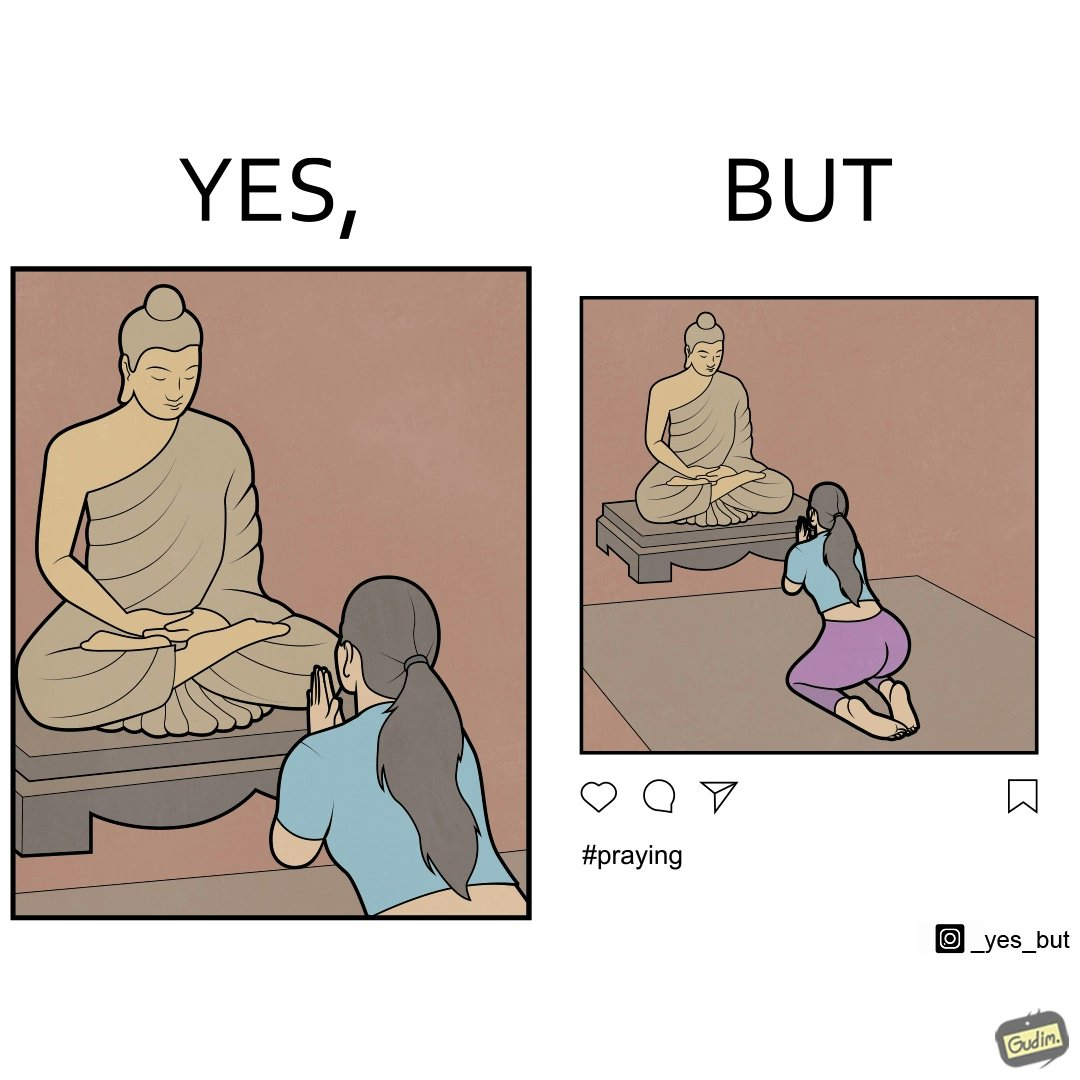Describe the content of this image. The image is ironic, because in the first image it seems that the woman is praying whole heartedly by bowing down in front of the statue but in the second image the same image is seen posted on the internet, so the woman was just posing for a photo to be posted on internet to gain followers or likes 